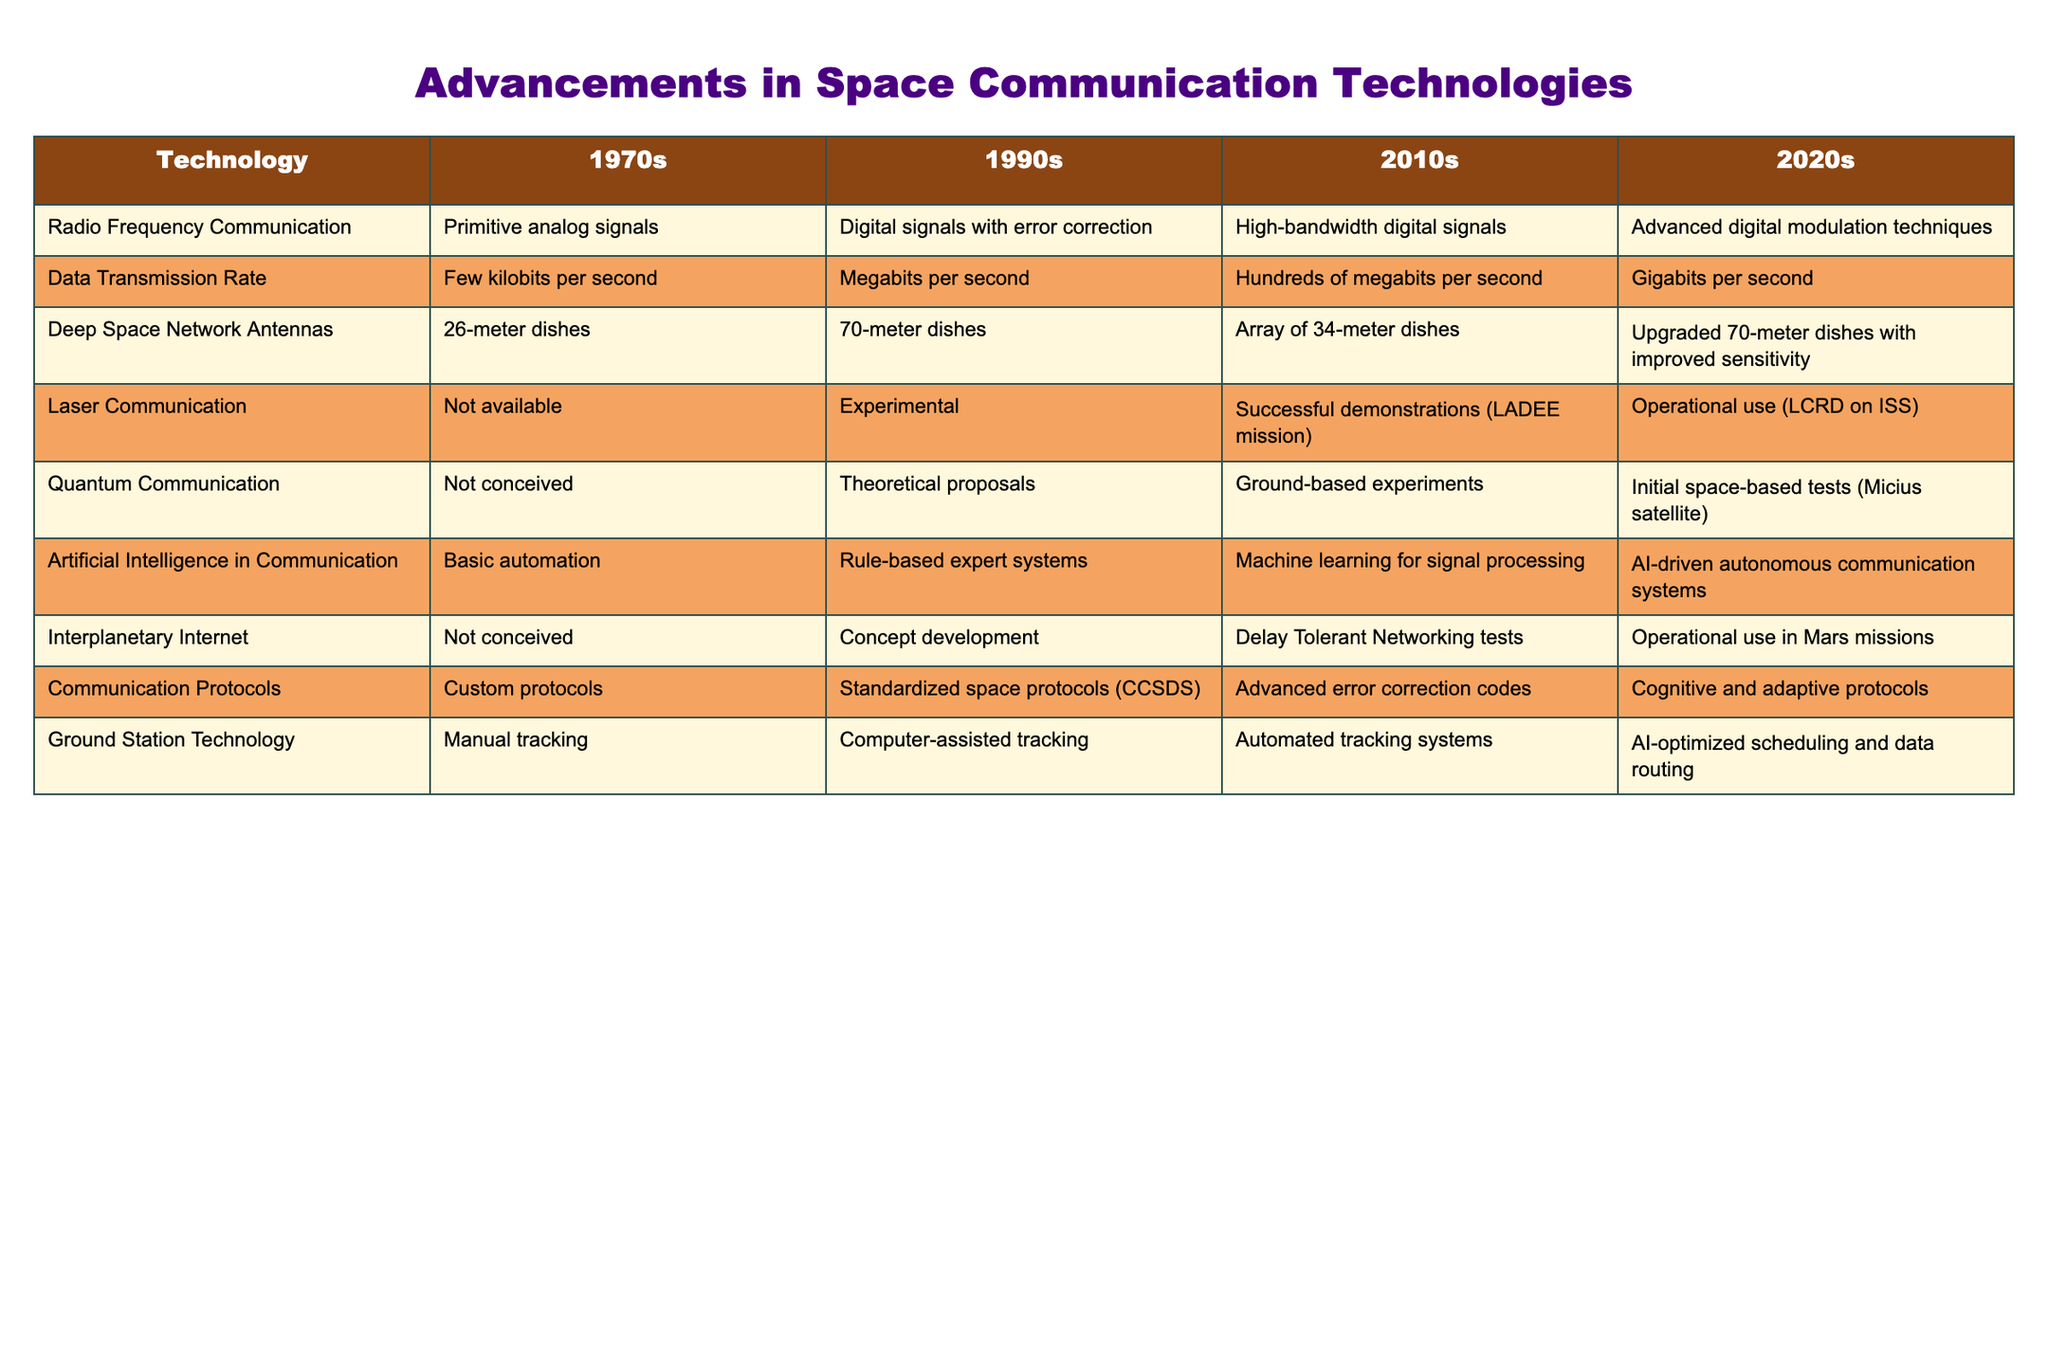What communication technology was not available in the 1970s? According to the table, the technology for Laser Communication was not available in the 1970s. This fact can be found in the row for Laser Communication under the 1970s column, which states "Not available."
Answer: Laser Communication What was the data transmission rate in the 1990s? Referring to the table, the data transmission rate in the 1990s was identified as "Megabits per second" as listed in that specific row and column.
Answer: Megabits per second Was Quantum Communication conceived in the 1970s? The table indicates that Quantum Communication was "Not conceived" in the 1970s, as described in the corresponding entry for that time period.
Answer: No Which decade saw the introduction of AI-driven autonomous communication systems? By examining the table, we can see that AI-driven autonomous communication systems were introduced in the 2020s, as outlined in the row for Artificial Intelligence in Communication in that column.
Answer: 2020s What is the difference in ground station technology from the 1990s to the 2020s? In the table, the ground station technology in the 1990s was "Computer-assisted tracking," while in the 2020s it is "AI-optimized scheduling and data routing." The difference can be noted as a transition from computer assistance to AI optimization.
Answer: Transition from computer-assisted to AI-optimized How many more data transmission rates (per second) were achieved in the 2020s compared to the 1990s? Looking at the data transmission rates, the 1990s achieved "Megabits per second" (which can be assumed as roughly 1 Megabit = 1000 Kilobits), and the 2020s achieved "Gigabits per second" (which equates to around 1000 Megabits). Thus, the difference in rates is 1000 Megabits (2020s) - 1 Megabit (1990s) = 999 Megabits per second.
Answer: 999 Megabits per second Did the size of the Deep Space Network antennas increase from the 1970s to the 2020s? Yes, the table confirms that the size of the antennas increased from 26-meter dishes in the 1970s to upgraded 70-meter dishes in the 2020s, demonstrating significant advancement.
Answer: Yes What was the status of Interplanetary Internet in the 1990s? Referring to the table, the Interplanetary Internet was in "Concept development" stage in the 1990s, as stated in that row for that period.
Answer: Concept development In what decade did laser communication become operational? According to the table, laser communication became operational in the 2020s as noted in the row for Laser Communication under that specific column.
Answer: 2020s 